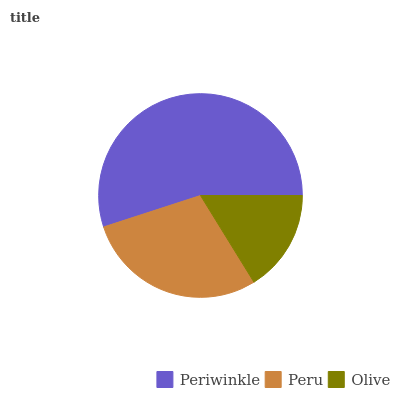Is Olive the minimum?
Answer yes or no. Yes. Is Periwinkle the maximum?
Answer yes or no. Yes. Is Peru the minimum?
Answer yes or no. No. Is Peru the maximum?
Answer yes or no. No. Is Periwinkle greater than Peru?
Answer yes or no. Yes. Is Peru less than Periwinkle?
Answer yes or no. Yes. Is Peru greater than Periwinkle?
Answer yes or no. No. Is Periwinkle less than Peru?
Answer yes or no. No. Is Peru the high median?
Answer yes or no. Yes. Is Peru the low median?
Answer yes or no. Yes. Is Periwinkle the high median?
Answer yes or no. No. Is Periwinkle the low median?
Answer yes or no. No. 